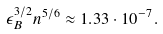<formula> <loc_0><loc_0><loc_500><loc_500>\epsilon _ { B } ^ { 3 / 2 } n ^ { 5 / 6 } \approx 1 . 3 3 \cdot 1 0 ^ { - 7 } .</formula> 